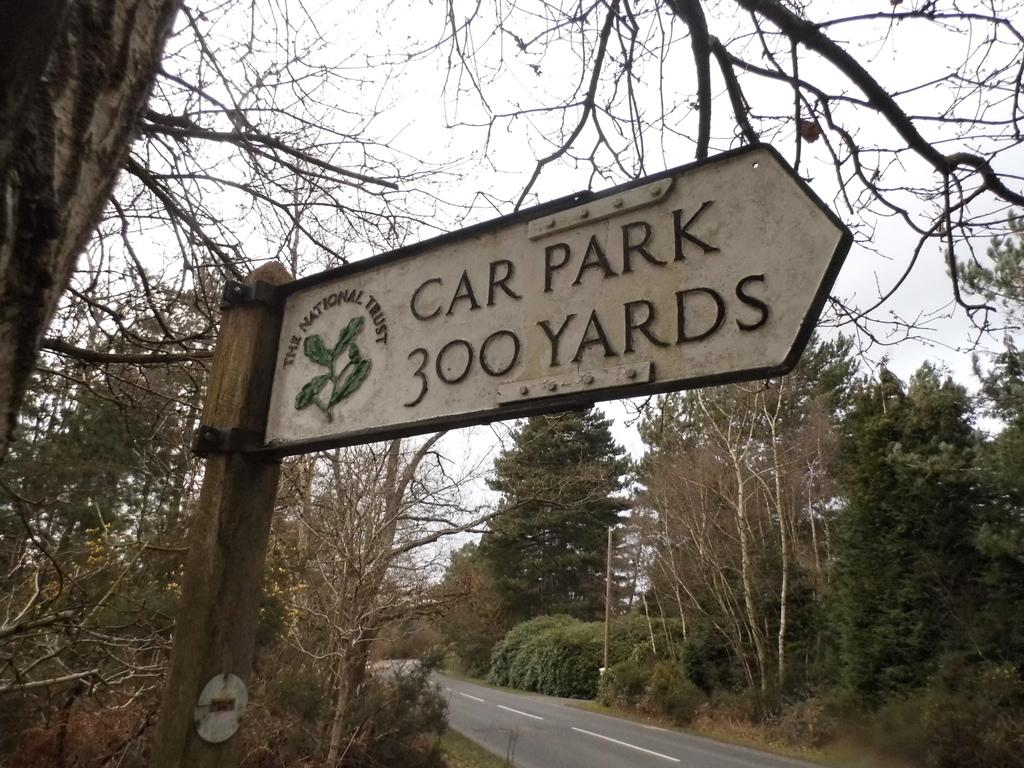What is attached to the pole in the image? There is a board with text written on it attached to the pole in the image. What type of vegetation can be seen in the image? Trees are visible in the image. What is the pole used for in the image? The pole is present in the image. What type of surface can be seen in the image? There is a road in the image. What is visible at the top of the image? The sky is visible in the image. What type of brick is used to build the home in the image? There is no home present in the image; it features a pole with a board and a road. What is the interest rate for the loan mentioned on the board in the image? There is no mention of a loan or interest rate on the board in the image; it only has text written on it. 